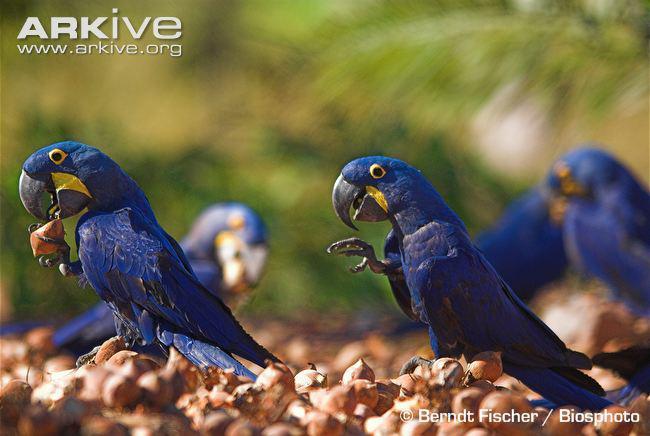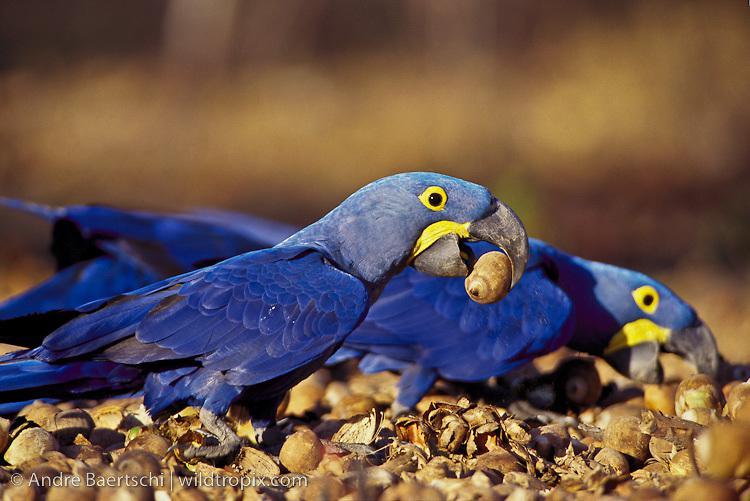The first image is the image on the left, the second image is the image on the right. Analyze the images presented: Is the assertion "There are three parrots." valid? Answer yes or no. No. The first image is the image on the left, the second image is the image on the right. For the images shown, is this caption "blue macaw are perched on a large pod in the tree" true? Answer yes or no. No. 